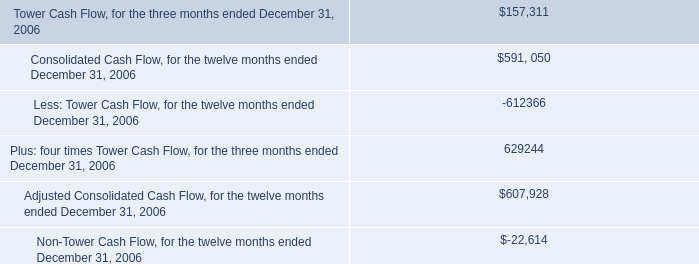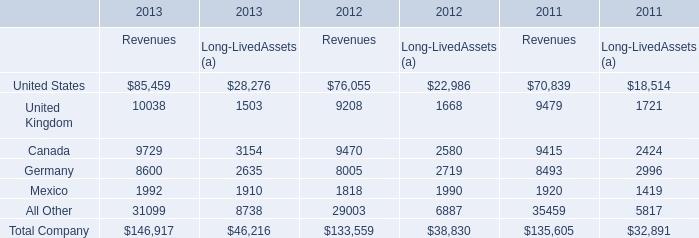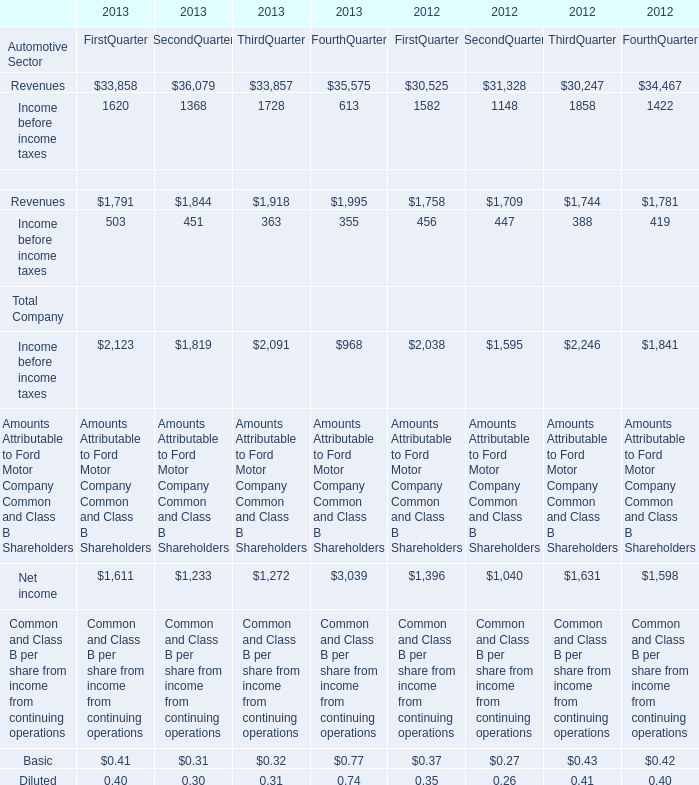What do all revenues of company sum up without those company smaller than 10000, in 2012? 
Computations: (((9208 + 9470) + 8005) + 1818)
Answer: 28501.0. 